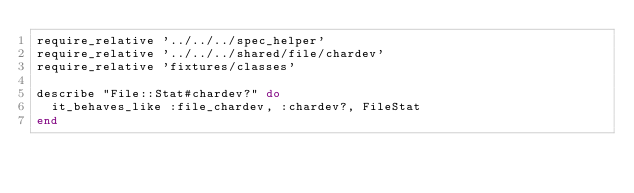Convert code to text. <code><loc_0><loc_0><loc_500><loc_500><_Ruby_>require_relative '../../../spec_helper'
require_relative '../../../shared/file/chardev'
require_relative 'fixtures/classes'

describe "File::Stat#chardev?" do
  it_behaves_like :file_chardev, :chardev?, FileStat
end
</code> 